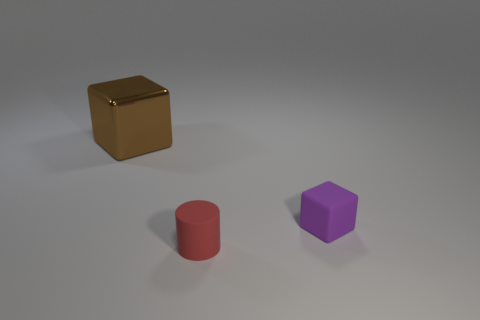Is there another blue cube that has the same size as the rubber block?
Provide a succinct answer. No. What color is the other tiny object that is made of the same material as the small purple thing?
Ensure brevity in your answer.  Red. There is a tiny object in front of the small purple block; how many red rubber cylinders are behind it?
Your response must be concise. 0. What material is the thing that is both behind the red cylinder and left of the purple thing?
Make the answer very short. Metal. Is the shape of the tiny rubber thing on the right side of the tiny rubber cylinder the same as  the large metallic thing?
Offer a terse response. Yes. Are there fewer tiny matte things than metallic cubes?
Provide a short and direct response. No. Are there more big cubes than large brown shiny cylinders?
Give a very brief answer. Yes. There is another thing that is the same shape as the big brown metal object; what is its size?
Your answer should be very brief. Small. Is the material of the red cylinder the same as the cube to the right of the large brown cube?
Offer a terse response. Yes. What number of things are either large green metal spheres or rubber things?
Offer a terse response. 2. 